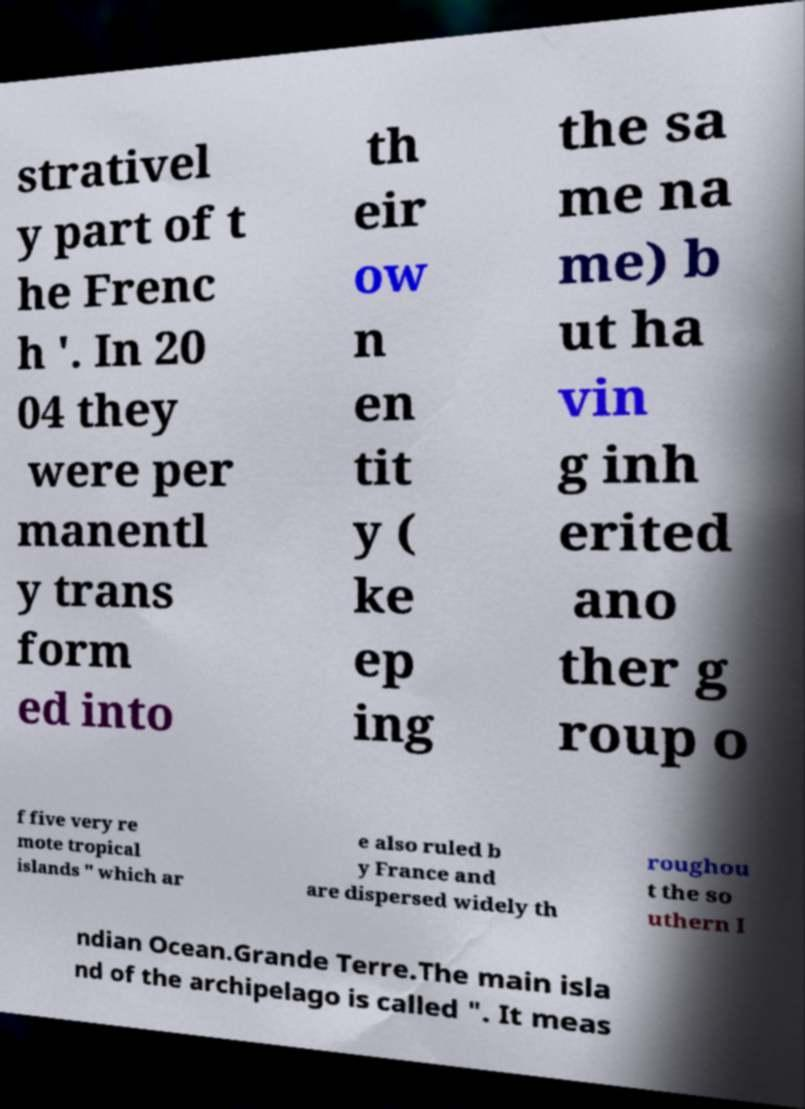Please identify and transcribe the text found in this image. strativel y part of t he Frenc h '. In 20 04 they were per manentl y trans form ed into th eir ow n en tit y ( ke ep ing the sa me na me) b ut ha vin g inh erited ano ther g roup o f five very re mote tropical islands " which ar e also ruled b y France and are dispersed widely th roughou t the so uthern I ndian Ocean.Grande Terre.The main isla nd of the archipelago is called ". It meas 